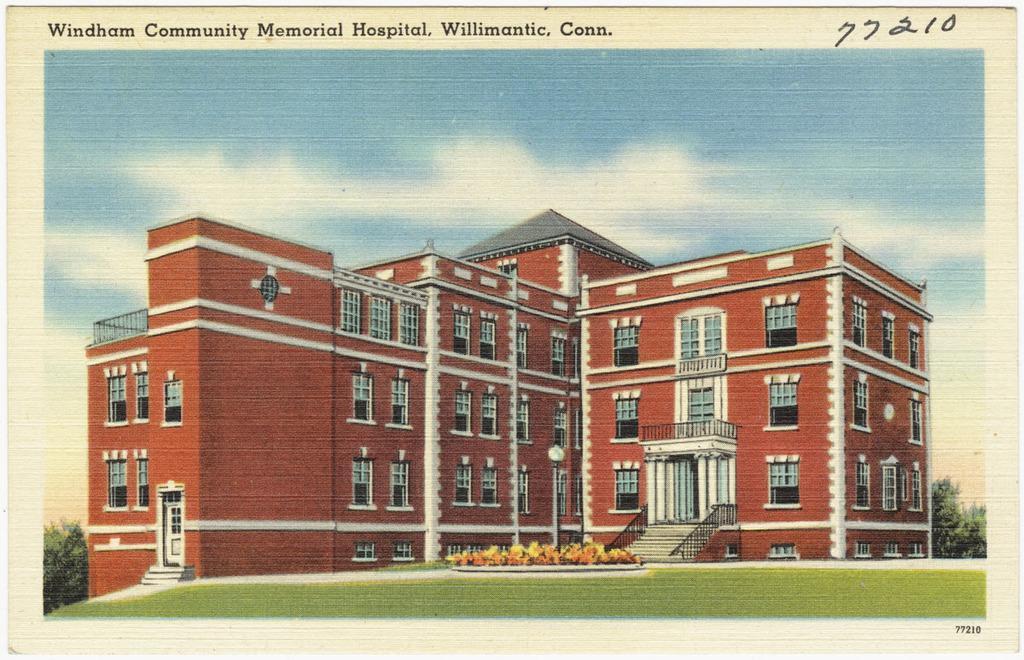Can you describe this image briefly? In the image we can see a paper, in the paper we can see a photo. In the photo we can see grass, plants, building, trees and poles. At the top of the image we can see some clouds in the sky and we can see some text. 